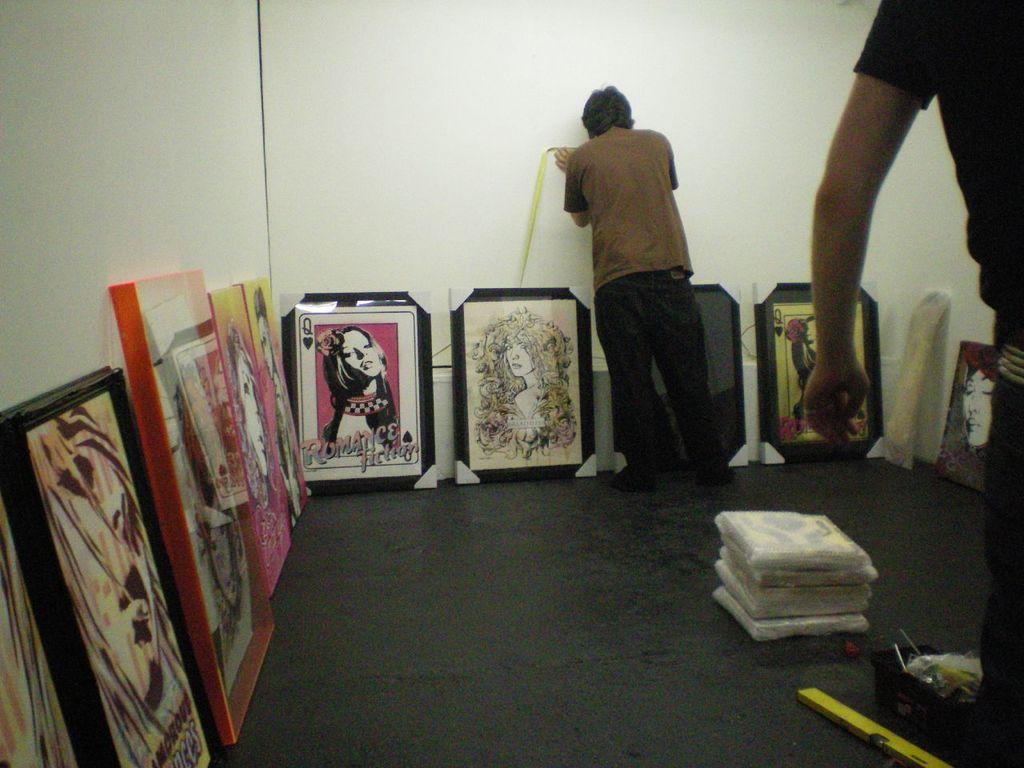Which playing card is featured in the painting in the middle?
Your response must be concise. Queen. 